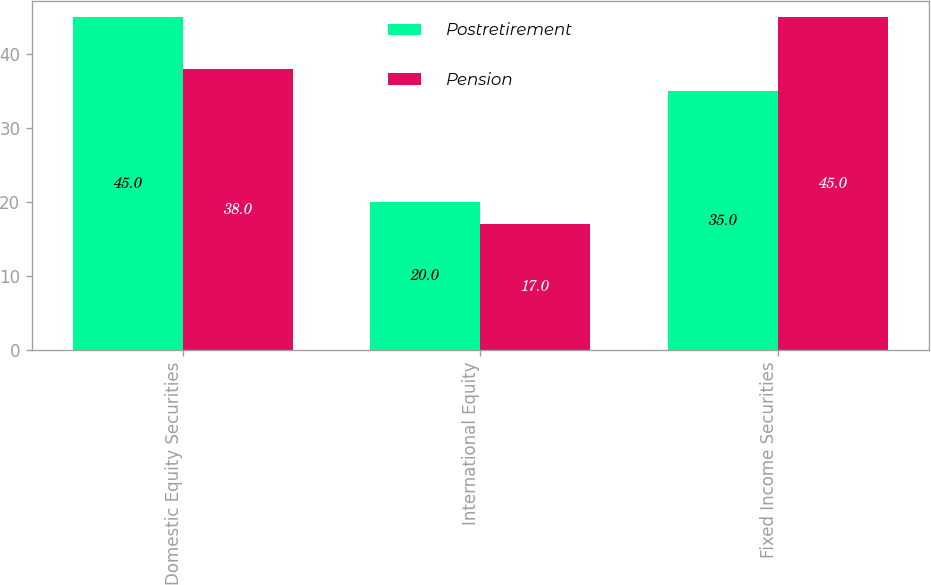Convert chart to OTSL. <chart><loc_0><loc_0><loc_500><loc_500><stacked_bar_chart><ecel><fcel>Domestic Equity Securities<fcel>International Equity<fcel>Fixed Income Securities<nl><fcel>Postretirement<fcel>45<fcel>20<fcel>35<nl><fcel>Pension<fcel>38<fcel>17<fcel>45<nl></chart> 